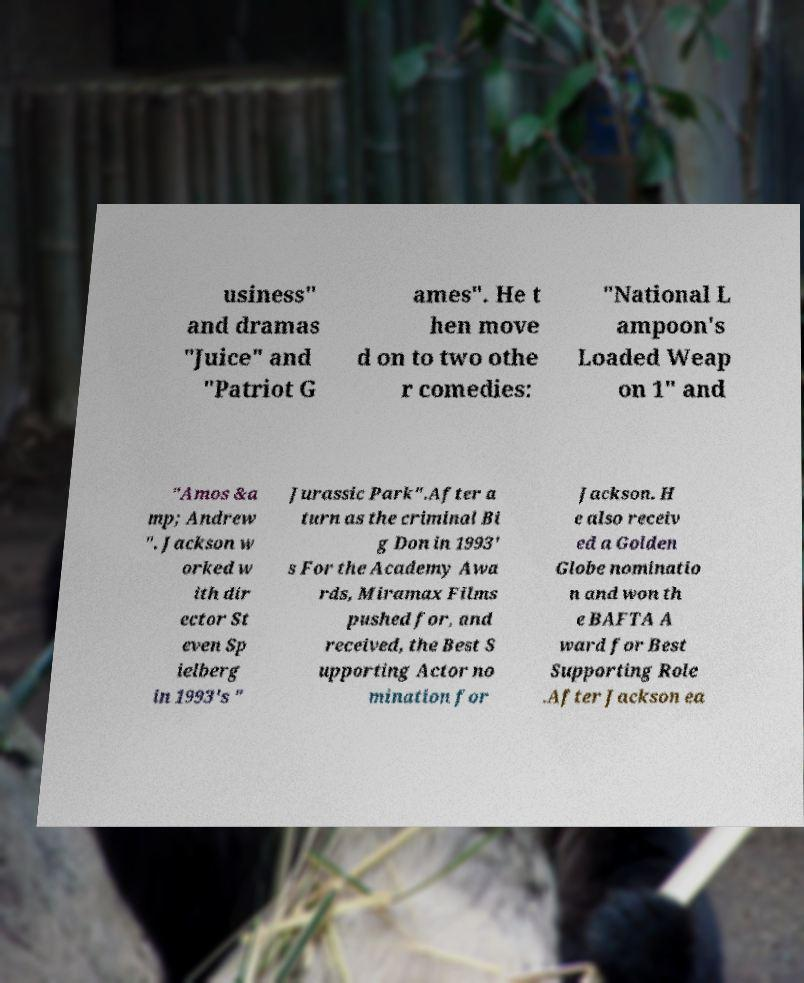Please read and relay the text visible in this image. What does it say? usiness" and dramas "Juice" and "Patriot G ames". He t hen move d on to two othe r comedies: "National L ampoon's Loaded Weap on 1" and "Amos &a mp; Andrew ". Jackson w orked w ith dir ector St even Sp ielberg in 1993's " Jurassic Park".After a turn as the criminal Bi g Don in 1993' s For the Academy Awa rds, Miramax Films pushed for, and received, the Best S upporting Actor no mination for Jackson. H e also receiv ed a Golden Globe nominatio n and won th e BAFTA A ward for Best Supporting Role .After Jackson ea 